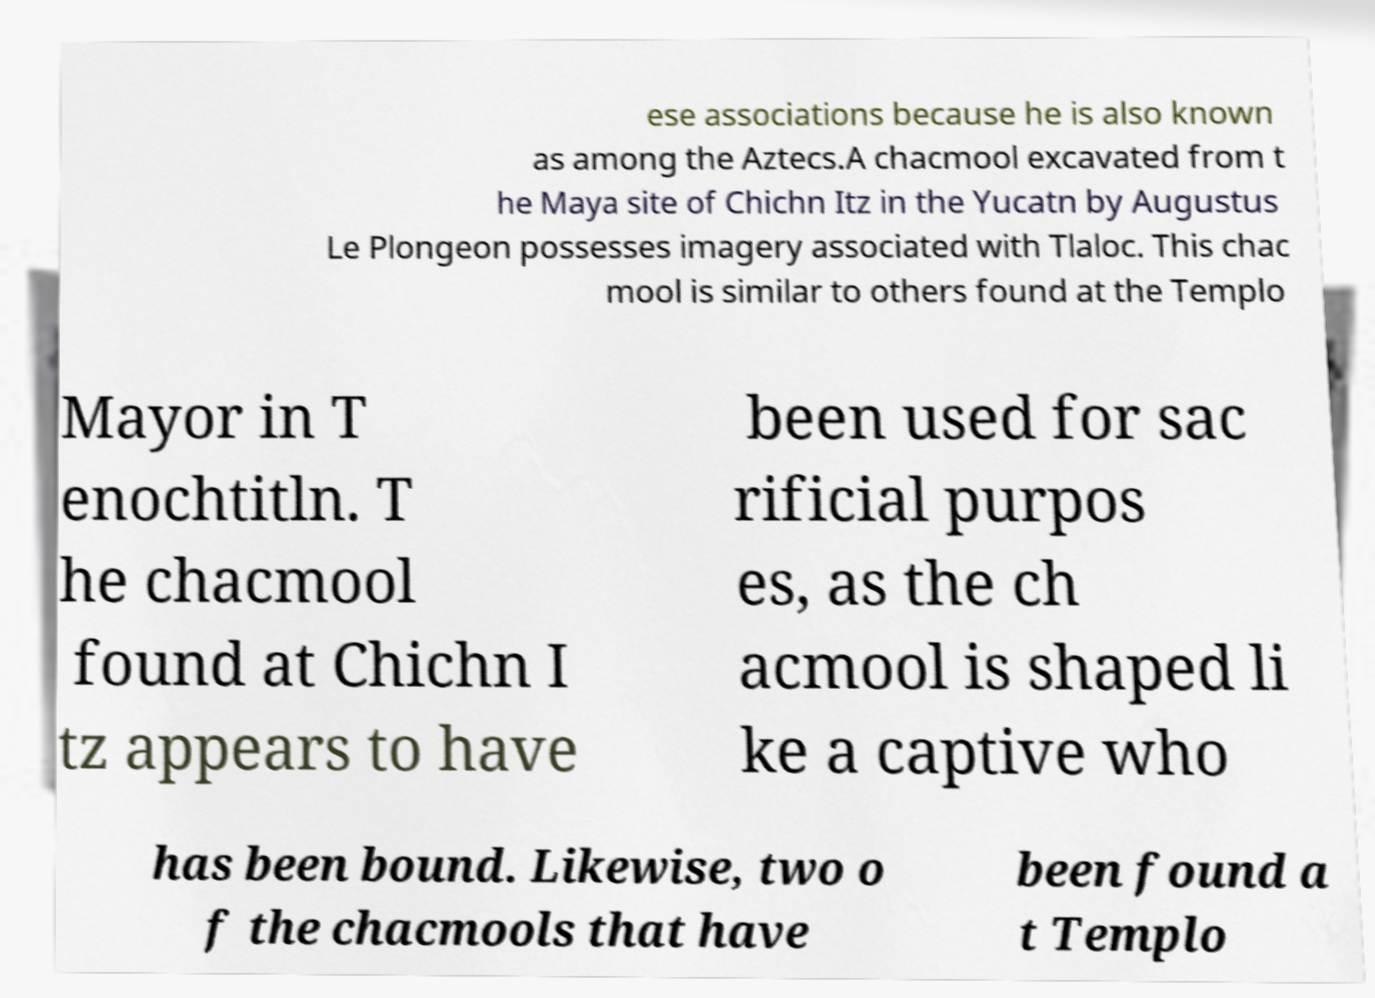What messages or text are displayed in this image? I need them in a readable, typed format. ese associations because he is also known as among the Aztecs.A chacmool excavated from t he Maya site of Chichn Itz in the Yucatn by Augustus Le Plongeon possesses imagery associated with Tlaloc. This chac mool is similar to others found at the Templo Mayor in T enochtitln. T he chacmool found at Chichn I tz appears to have been used for sac rificial purpos es, as the ch acmool is shaped li ke a captive who has been bound. Likewise, two o f the chacmools that have been found a t Templo 